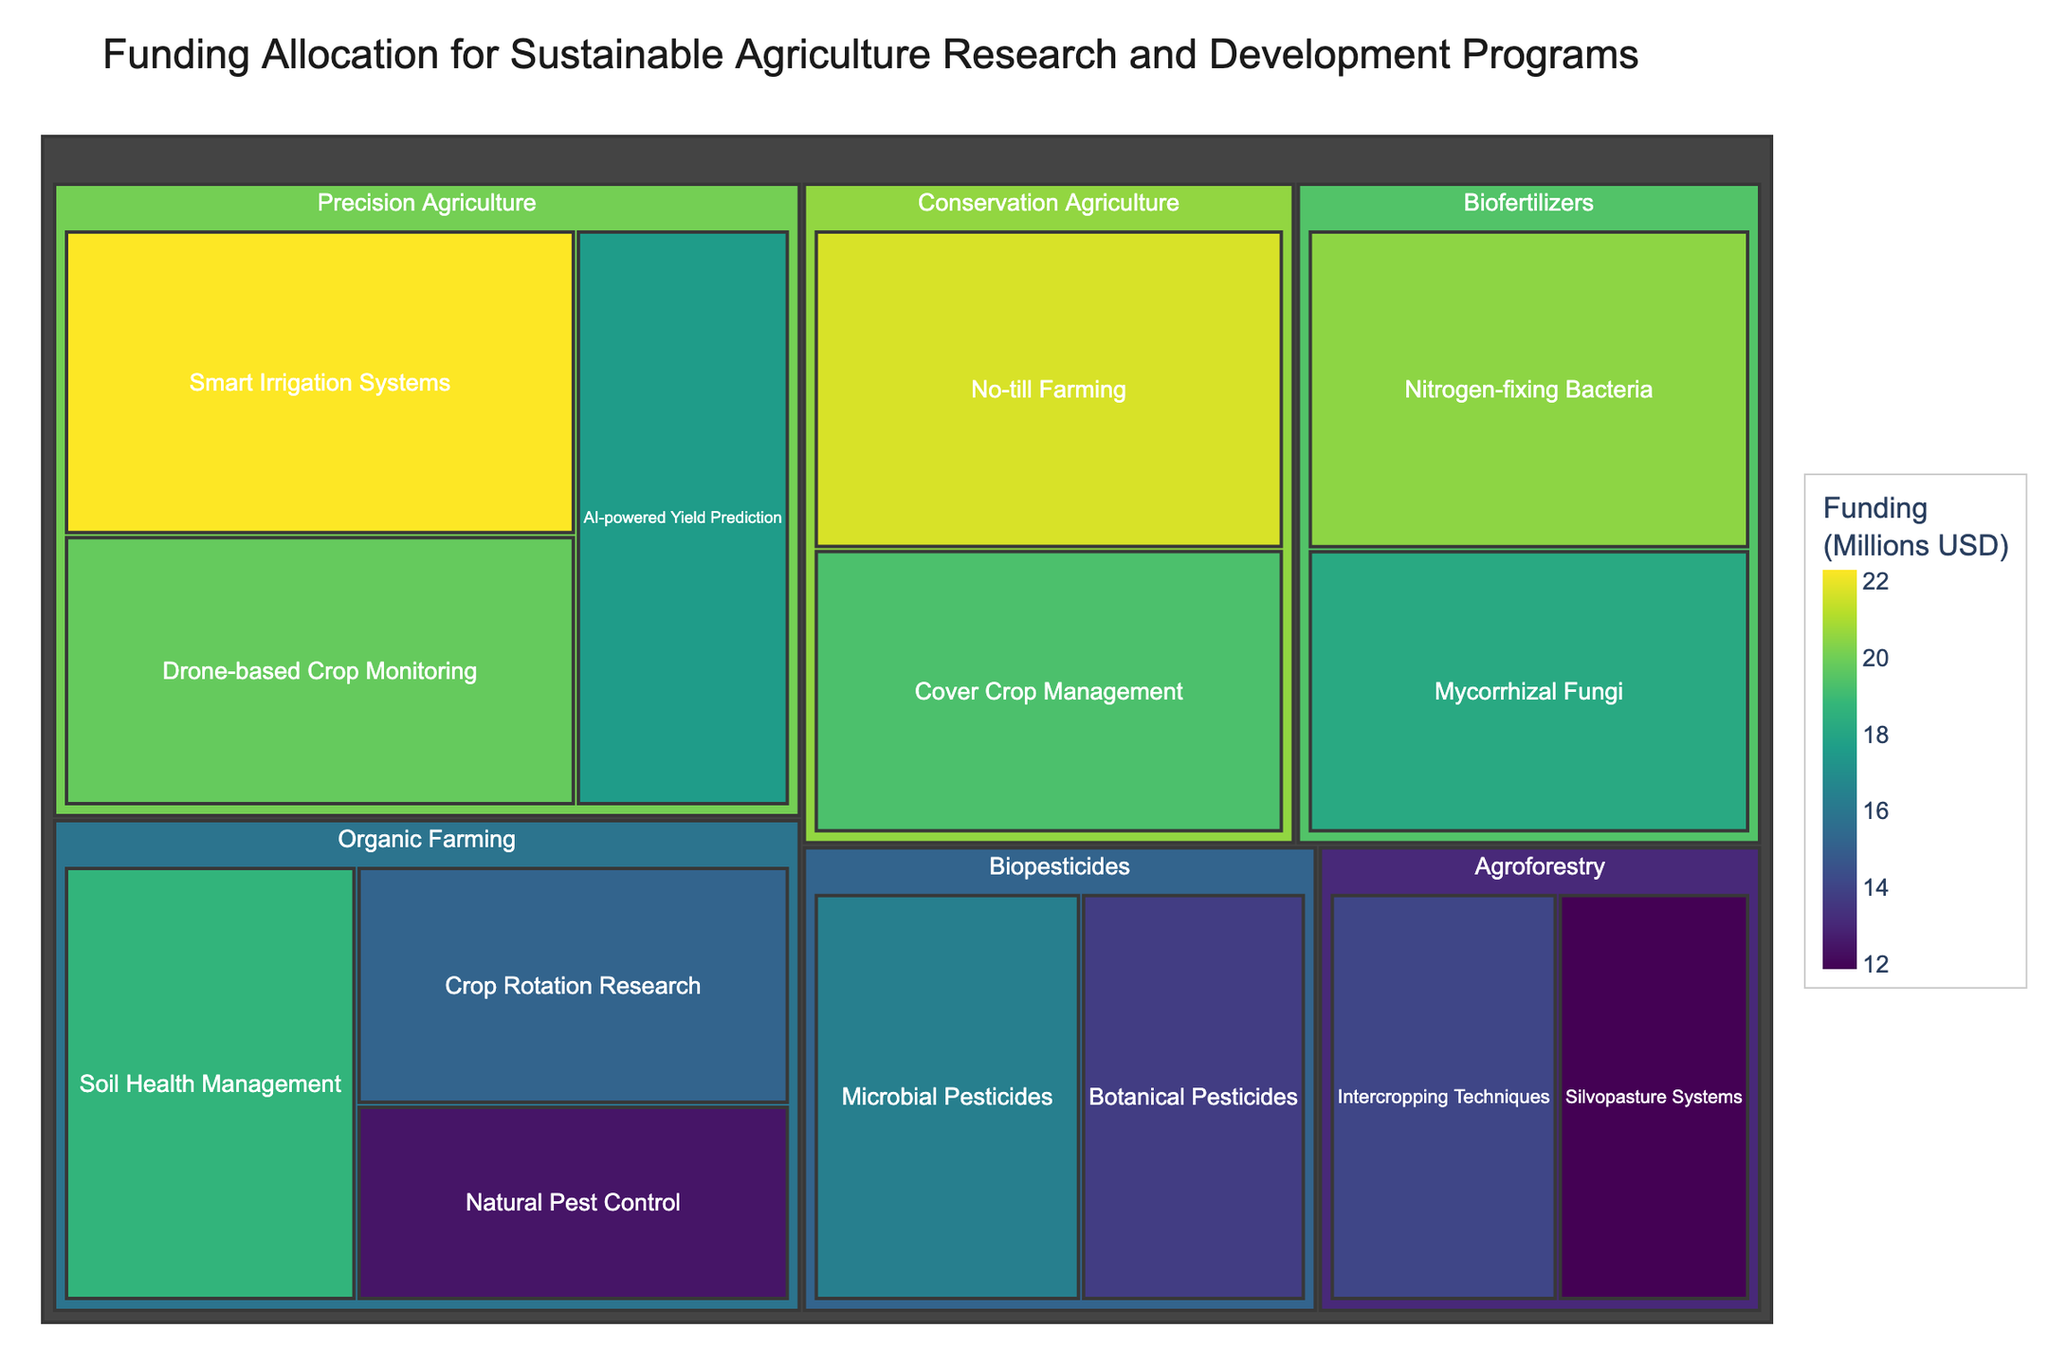What is the main title of the treemap? The main title is usually displayed at the top of the treemap and gives an overview of what the figure represents. It helps the viewer understand the context of the data.
Answer: "Funding Allocation for Sustainable Agriculture Research and Development Programs" How much funding is allocated to Smart Irrigation Systems under Precision Agriculture? Located in the Precision Agriculture category in the treemap, Smart Irrigation Systems can be found as a subcategory. The funding allocated to it is displayed in millions USD.
Answer: 22.3 million USD Which category receives the highest total funding, and how much is it? You need to sum the funding of all subcategories under each category to identify which one has the highest total funding.
Answer: Precision Agriculture, 59.7 million USD (22.3 + 19.8 + 17.6) Compare the funding for Microbial Pesticides and Botanical Pesticides. Which one receives more funding, and by how much? Both subcategories are under the Biopesticides category. You need to compare their funding amounts and find the difference.
Answer: Microbial Pesticides receives more funding by 2.6 million USD (16.4 - 13.8) What is the total funding allocated to Conservation Agriculture? Find the subcategories under Conservation Agriculture and add their funding amounts together.
Answer: 41 million USD (21.7 + 19.3) Which subcategory receives the least funding, and how much is it? Look for the subcategory with the smallest block in terms of funding across all categories in the treemap.
Answer: Silvopasture Systems, 11.9 million USD How does the funding for AI-powered Yield Prediction compare to Cover Crop Management? Compare the funding amounts listed for AI-powered Yield Prediction under Precision Agriculture and Cover Crop Management under Conservation Agriculture.
Answer: AI-powered Yield Prediction has 1.7 million USD less funding than Cover Crop Management (19.3 - 17.6) Which subcategory within Organic Farming receives the highest funding? Find the subcategories under Organic Farming and compare their funding amounts to identify the highest one.
Answer: Soil Health Management, 18.7 million USD What is the average funding for all subcategories under Biofertilizers? Sum the funding amounts for all subcategories under Biofertilizers and then divide by the number of subcategories.
Answer: 19.35 million USD [(20.5 + 18.2) / 2] Based on the treemap color scale, which subcategory likely appears in the darkest shade, and how is the color scale used here? The darkest shade generally represents the highest funding value according to the Viridis color scale used in the treemap. Identify the subcategory with the highest funding to determine the corresponding color.
Answer: Smart Irrigation Systems, the darkest shade represents 22.3 million USD 